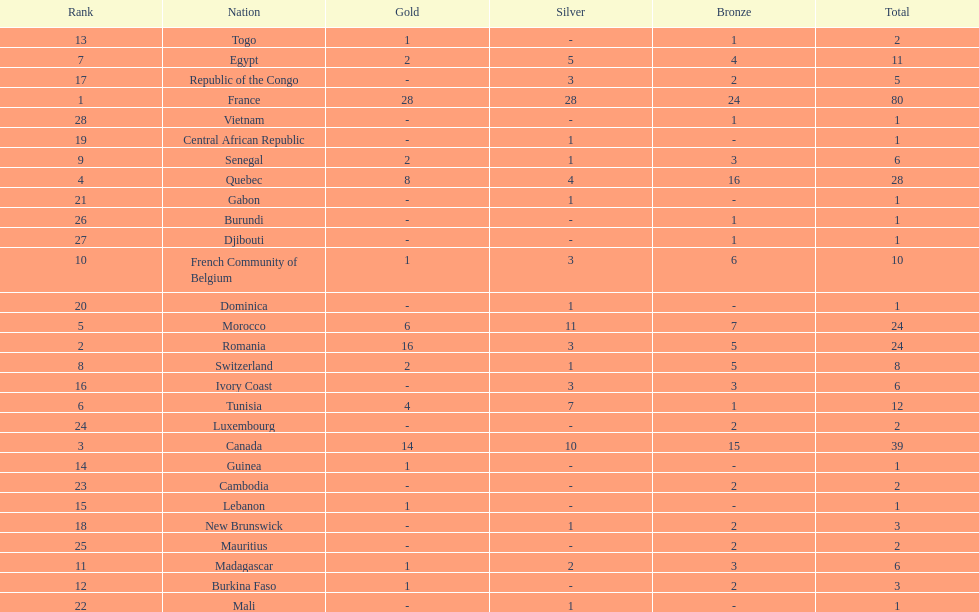How many nations won at least 10 medals? 8. 